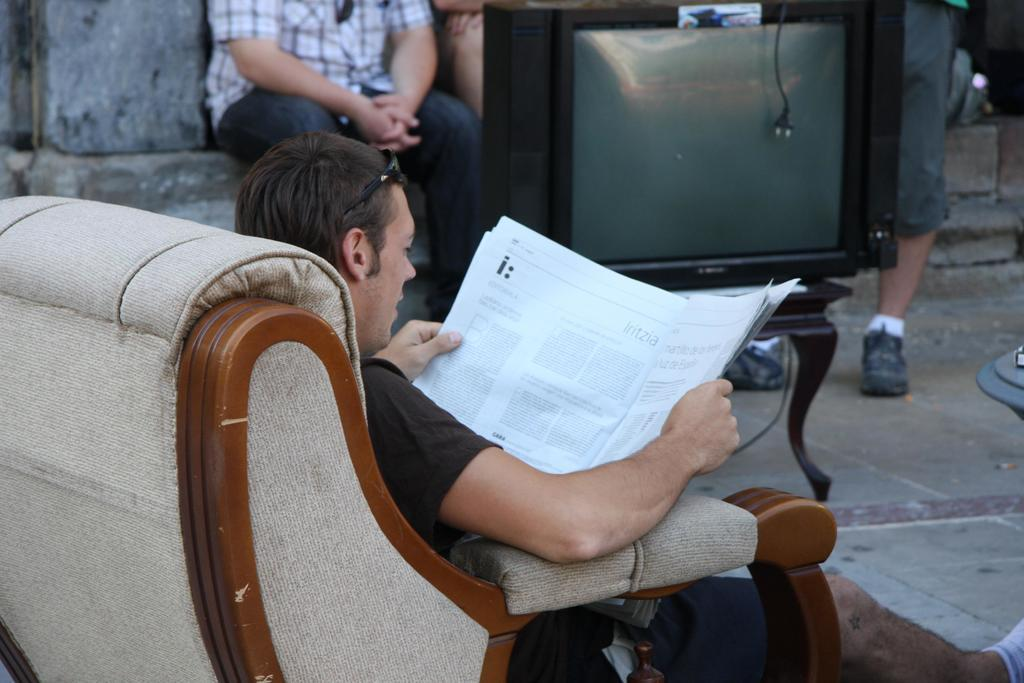What is the person in the image doing? The person is sitting on a chair in the image. What is the person holding in the image? The person is holding a newspaper. What electronic device is present in the image? There is a television in the image. Can you describe the setting in the background of the image? There are people visible in the background of the image. What type of cow can be seen standing next to the person in the image? There is no cow present in the image; the person is sitting on a chair and holding a newspaper. 